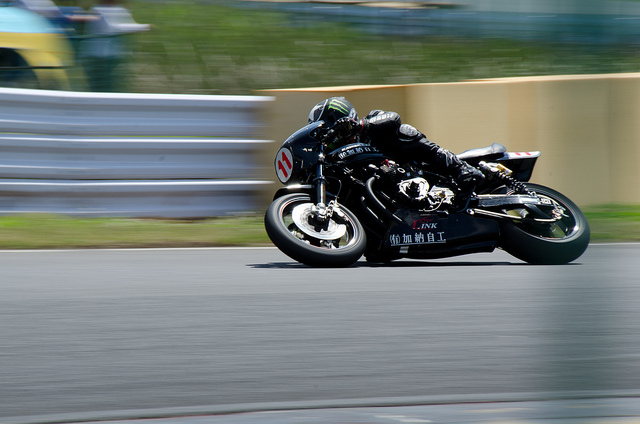Extract all visible text content from this image. LINK L 11 